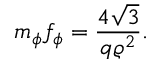Convert formula to latex. <formula><loc_0><loc_0><loc_500><loc_500>m _ { \phi } f _ { \phi } = \frac { 4 \sqrt { 3 } } { q \varrho ^ { 2 } } .</formula> 